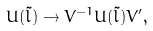<formula> <loc_0><loc_0><loc_500><loc_500>U ( \tilde { l } ) \rightarrow V ^ { - 1 } U ( \tilde { l } ) V ^ { \prime } ,</formula> 